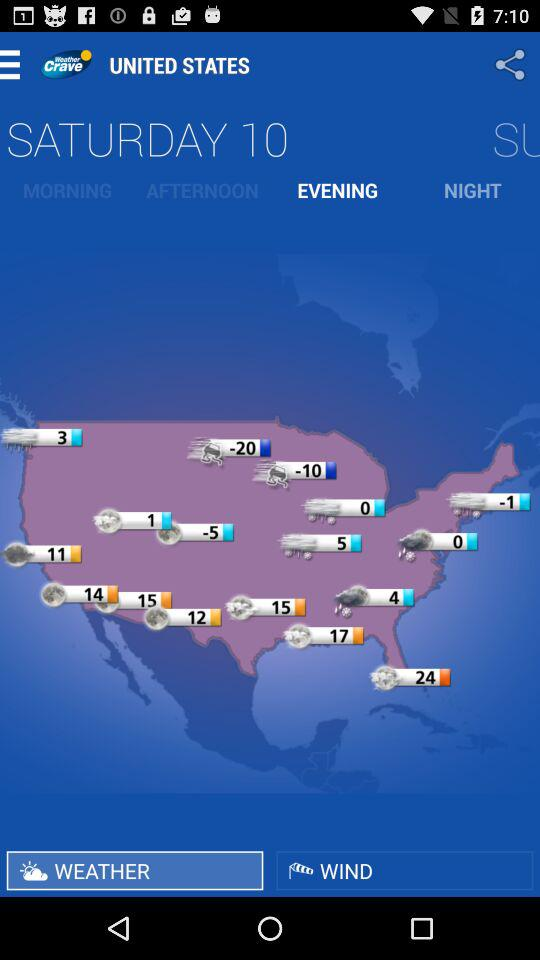Which day is selected to get the weather forecast? The day selected to get the weather forecast is Saturday. 